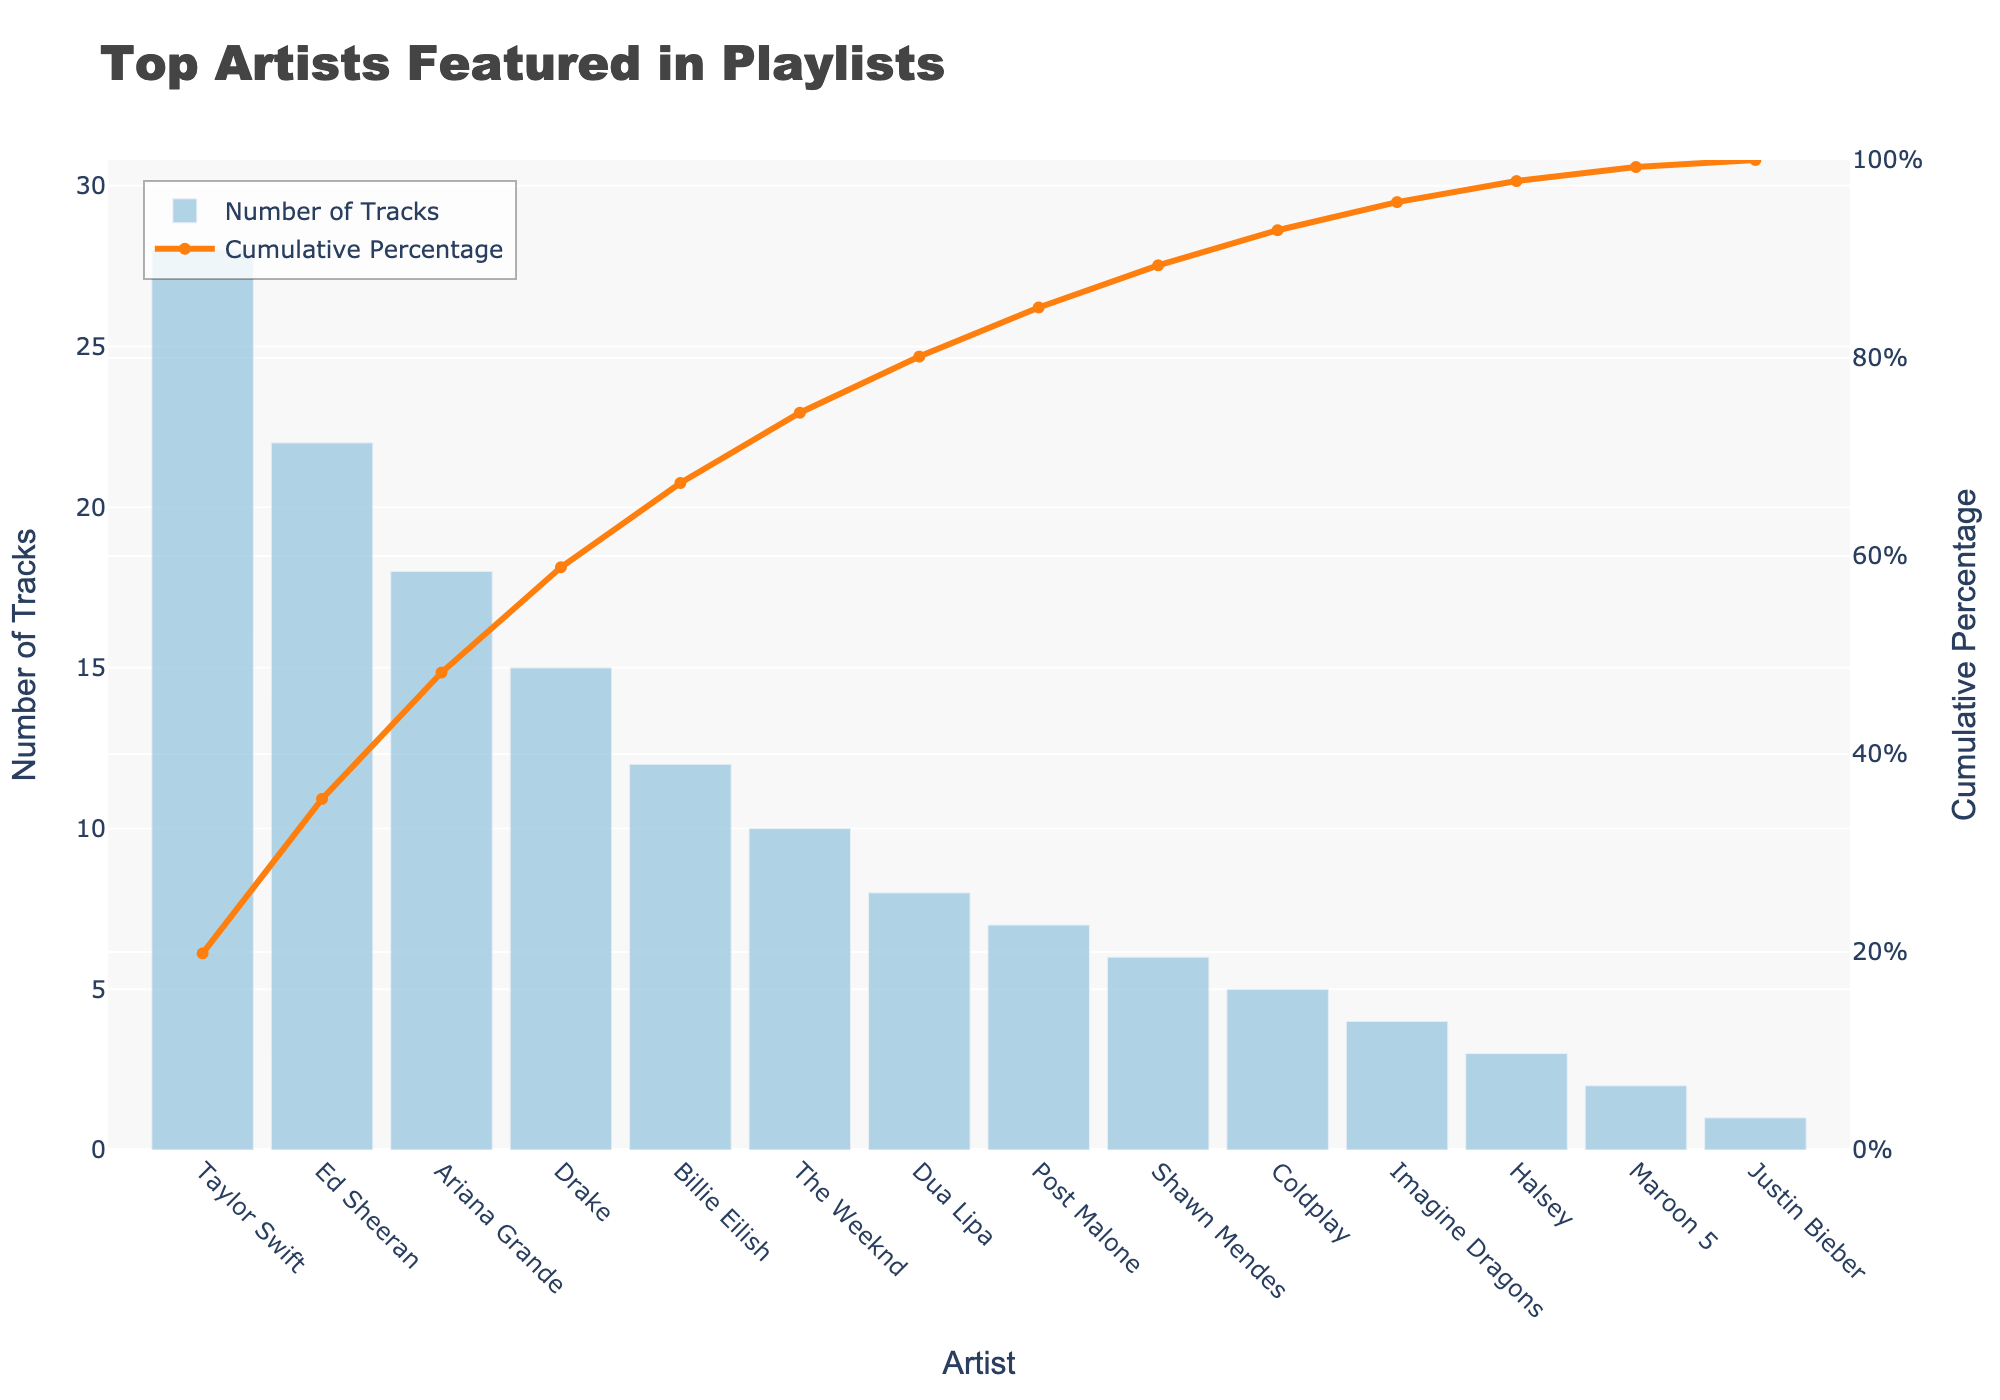What's the title of the chart? The title is displayed at the top center of the figure. It reads "Top Artists Featured in Playlists".
Answer: Top Artists Featured in Playlists How many tracks does Taylor Swift have in the playlists? Taylor Swift's bar is the highest, and the label at the top of the bar reads 28.
Answer: 28 What’s the cumulative percentage of tracks for Ariana Grande? The line chart for cumulative percentage intersects Ariana Grande's label, and the value on the y-axis (right side) reads approximately 46%.
Answer: Approximately 46% How many artists have more than 10 tracks in the playlists? By visually counting the bars with heights greater than the 10-track mark on the left y-axis, there are 5 artists: Taylor Swift, Ed Sheeran, Ariana Grande, Drake, and Billie Eilish.
Answer: 5 Which artist has the lowest number of tracks, and how many tracks do they have? The shortest bar belongs to Justin Bieber, and its label reads 1.
Answer: Justin Bieber, 1 What is the cumulative percentage after The Weeknd's tracks? The line chart marks The Weeknd’s value on the cumulative percentage axis, which shows around 65%.
Answer: Approximately 65% What's the difference in the number of tracks between Ed Sheeran and Billie Eilish? Ed Sheeran has 22 tracks, while Billie Eilish has 12. The difference is calculated as 22 - 12.
Answer: 10 How many artists are featured in the plot? By counting the bars, there are 14 artists presented in the chart.
Answer: 14 Does Post Malone have more tracks or less than Coldplay? Post Malone’s bar is higher than Coldplay’s. Post Malone has 7 tracks, while Coldplay has 5.
Answer: More What percentage of the tracks does Shawn Mendes contribute cumulatively? The line chart intersects with Shawn Mendes' label, pointing to a cumulative percentage of around 91%.
Answer: Approximately 91% What is the combined number of tracks for Dua Lipa and Imagine Dragons? Dua Lipa has 8 tracks and Imagine Dragons have 4. The sum is 8 + 4.
Answer: 12 